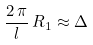Convert formula to latex. <formula><loc_0><loc_0><loc_500><loc_500>\frac { 2 \, \pi } { l } \, R _ { 1 } \approx \Delta</formula> 